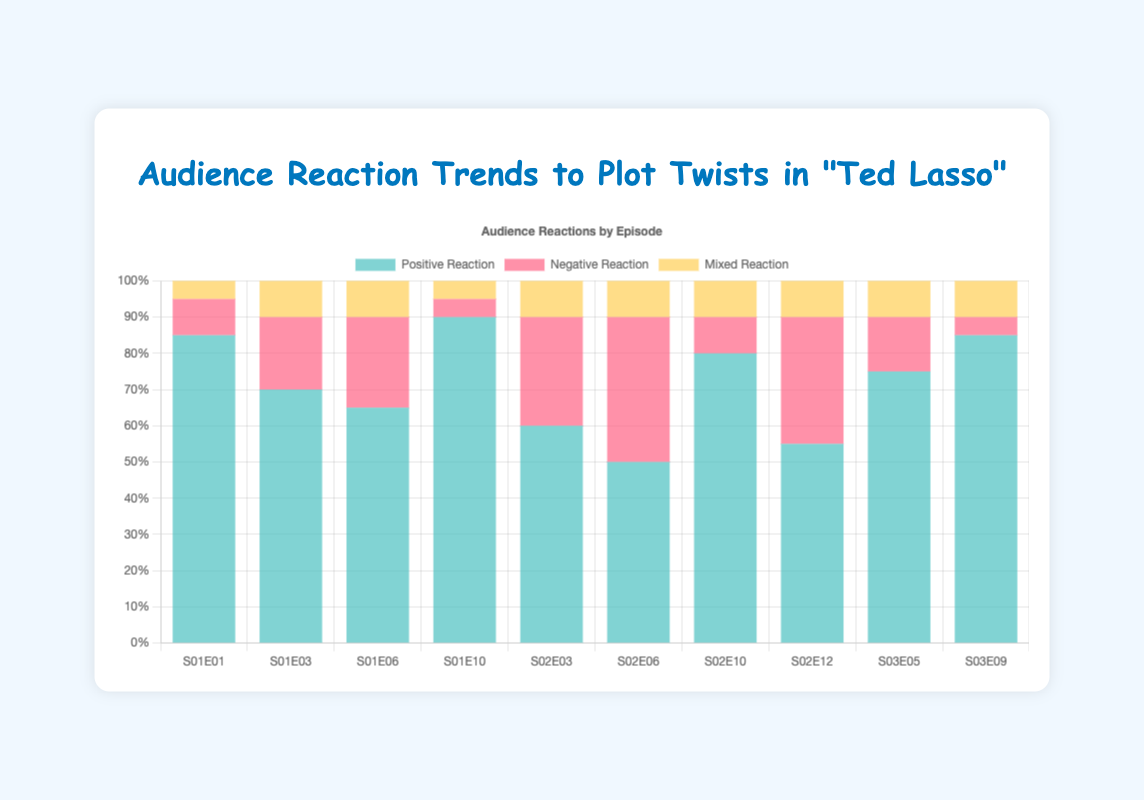Which episode received the highest positive reaction? Observe the bar heights for the 'Positive Reaction' group. The tallest bar corresponds to S01E10 'Ted's Panic Attack' at 90%.
Answer: S01E10 'Ted's Panic Attack' Which episode had the highest negative reaction, and what was the percentage? Look for the tallest bar in the 'Negative Reaction' group. S02E06 'Rebecca and Sam' has the highest negative reaction at 40%.
Answer: S02E06 'Rebecca and Sam', 40% What is the sum of the mixed reactions in Season 1? Add the mixed reactions for S01E01, S01E03, S01E06, and S01E10: 5 + 10 + 10 + 5 = 30.
Answer: 30 How does the mixed reaction to 'Rebecca's Plan Revealed' (S01E03) compare to 'Nate's Ambition' (S02E03)? Identify the bar heights for mixed reactions in these episodes. Both have mixed reactions of 10%.
Answer: Equal (10% each) What is the average positive reaction across all episodes? Add all positive reactions: 85 + 70 + 65 + 90 + 60 + 50 + 80 + 55 + 75 + 85 = 715. Divide by the number of episodes (10): 715/10 = 71.5.
Answer: 71.5% Is the mixed reaction for 'Ted Becomes Coach' higher or lower than for 'Richmond's Winning Streak'? Compare the mixed reaction bars for S01E01 and S03E09. Both are 5% and 10% respectively.
Answer: Lower Which season has the overall highest positive reaction average? Calculate the average positive reaction for each season: Season 1: (85+70+65+90)/4 = 77.5; Season 2: (60+50+80+55)/4 = 61.25; Season 3: (75+85)/2 = 80. Season 3 has the highest average.
Answer: Season 3 What is the total percentage of negative reactions across all episodes in Season 2? Sum negative reactions for S02E03, S02E06, S02E10, and S02E12: 30 + 40 + 10 + 35 = 115.
Answer: 115% Between 'Rebecca and Sam' (S02E06) and 'Nate's Betrayal' (S02E12), which has a higher overall audience reaction (sum of positive, negative, and mixed)? Sum reactions for each: S02E06: 50+40+10 = 100, S02E12: 55+35+10 = 100. Both are equal.
Answer: Equal (100%) Which episode has the lowest combined negative and mixed reaction, and what is the value? Find the episode with the smallest sum of negative and mixed reaction bars: S01E10 'Ted's Panic Attack' has 5 (negative) + 5 (mixed) = 10.
Answer: S01E10 'Ted's Panic Attack', 10% 